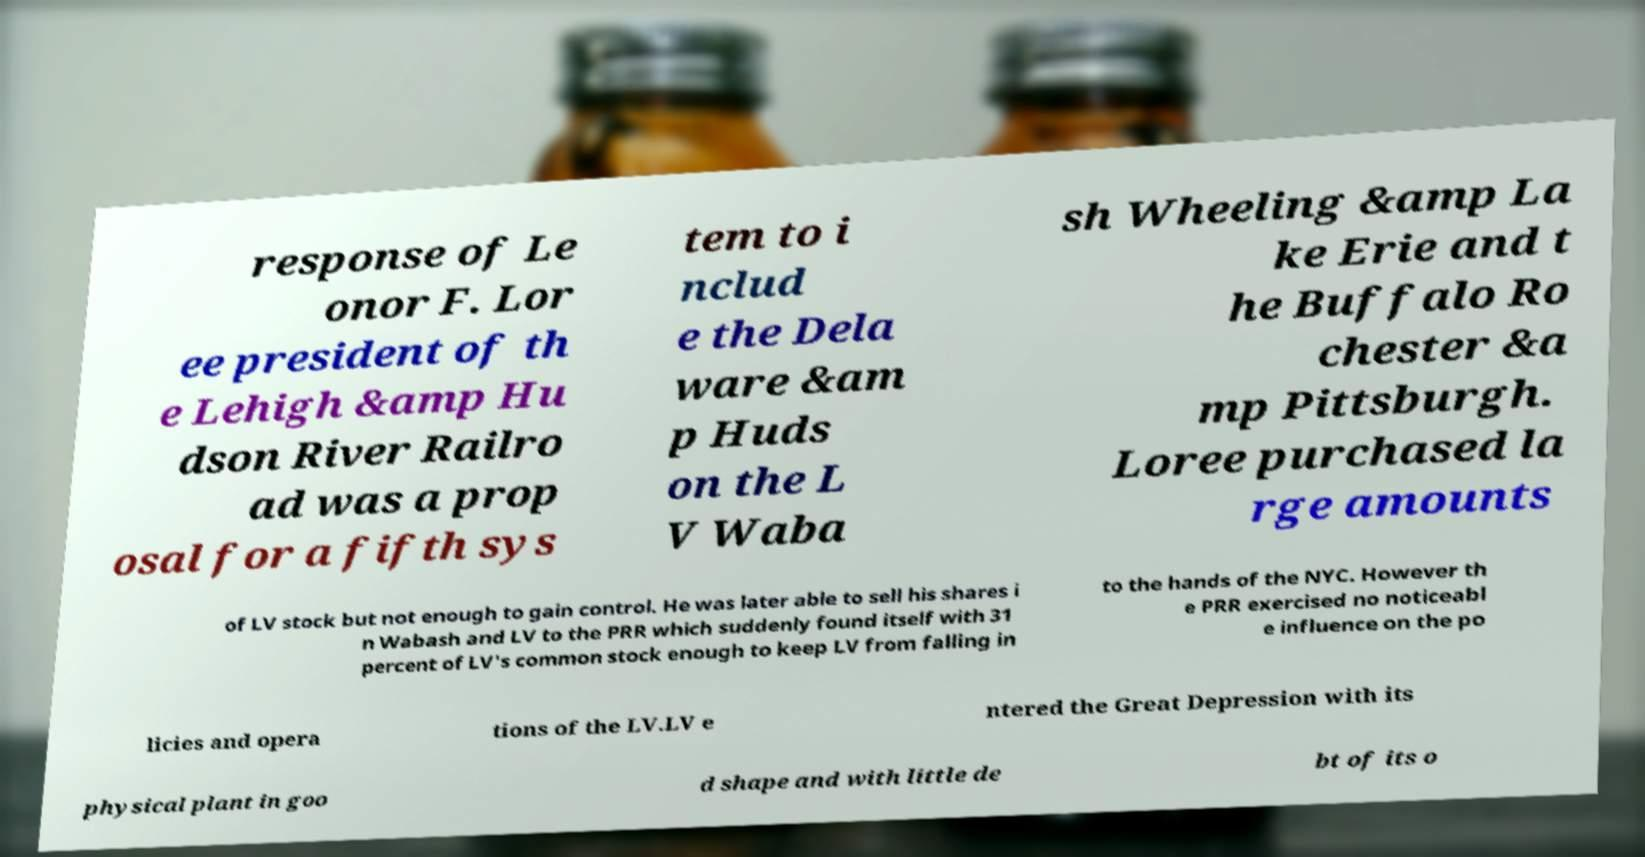I need the written content from this picture converted into text. Can you do that? response of Le onor F. Lor ee president of th e Lehigh &amp Hu dson River Railro ad was a prop osal for a fifth sys tem to i nclud e the Dela ware &am p Huds on the L V Waba sh Wheeling &amp La ke Erie and t he Buffalo Ro chester &a mp Pittsburgh. Loree purchased la rge amounts of LV stock but not enough to gain control. He was later able to sell his shares i n Wabash and LV to the PRR which suddenly found itself with 31 percent of LV's common stock enough to keep LV from falling in to the hands of the NYC. However th e PRR exercised no noticeabl e influence on the po licies and opera tions of the LV.LV e ntered the Great Depression with its physical plant in goo d shape and with little de bt of its o 